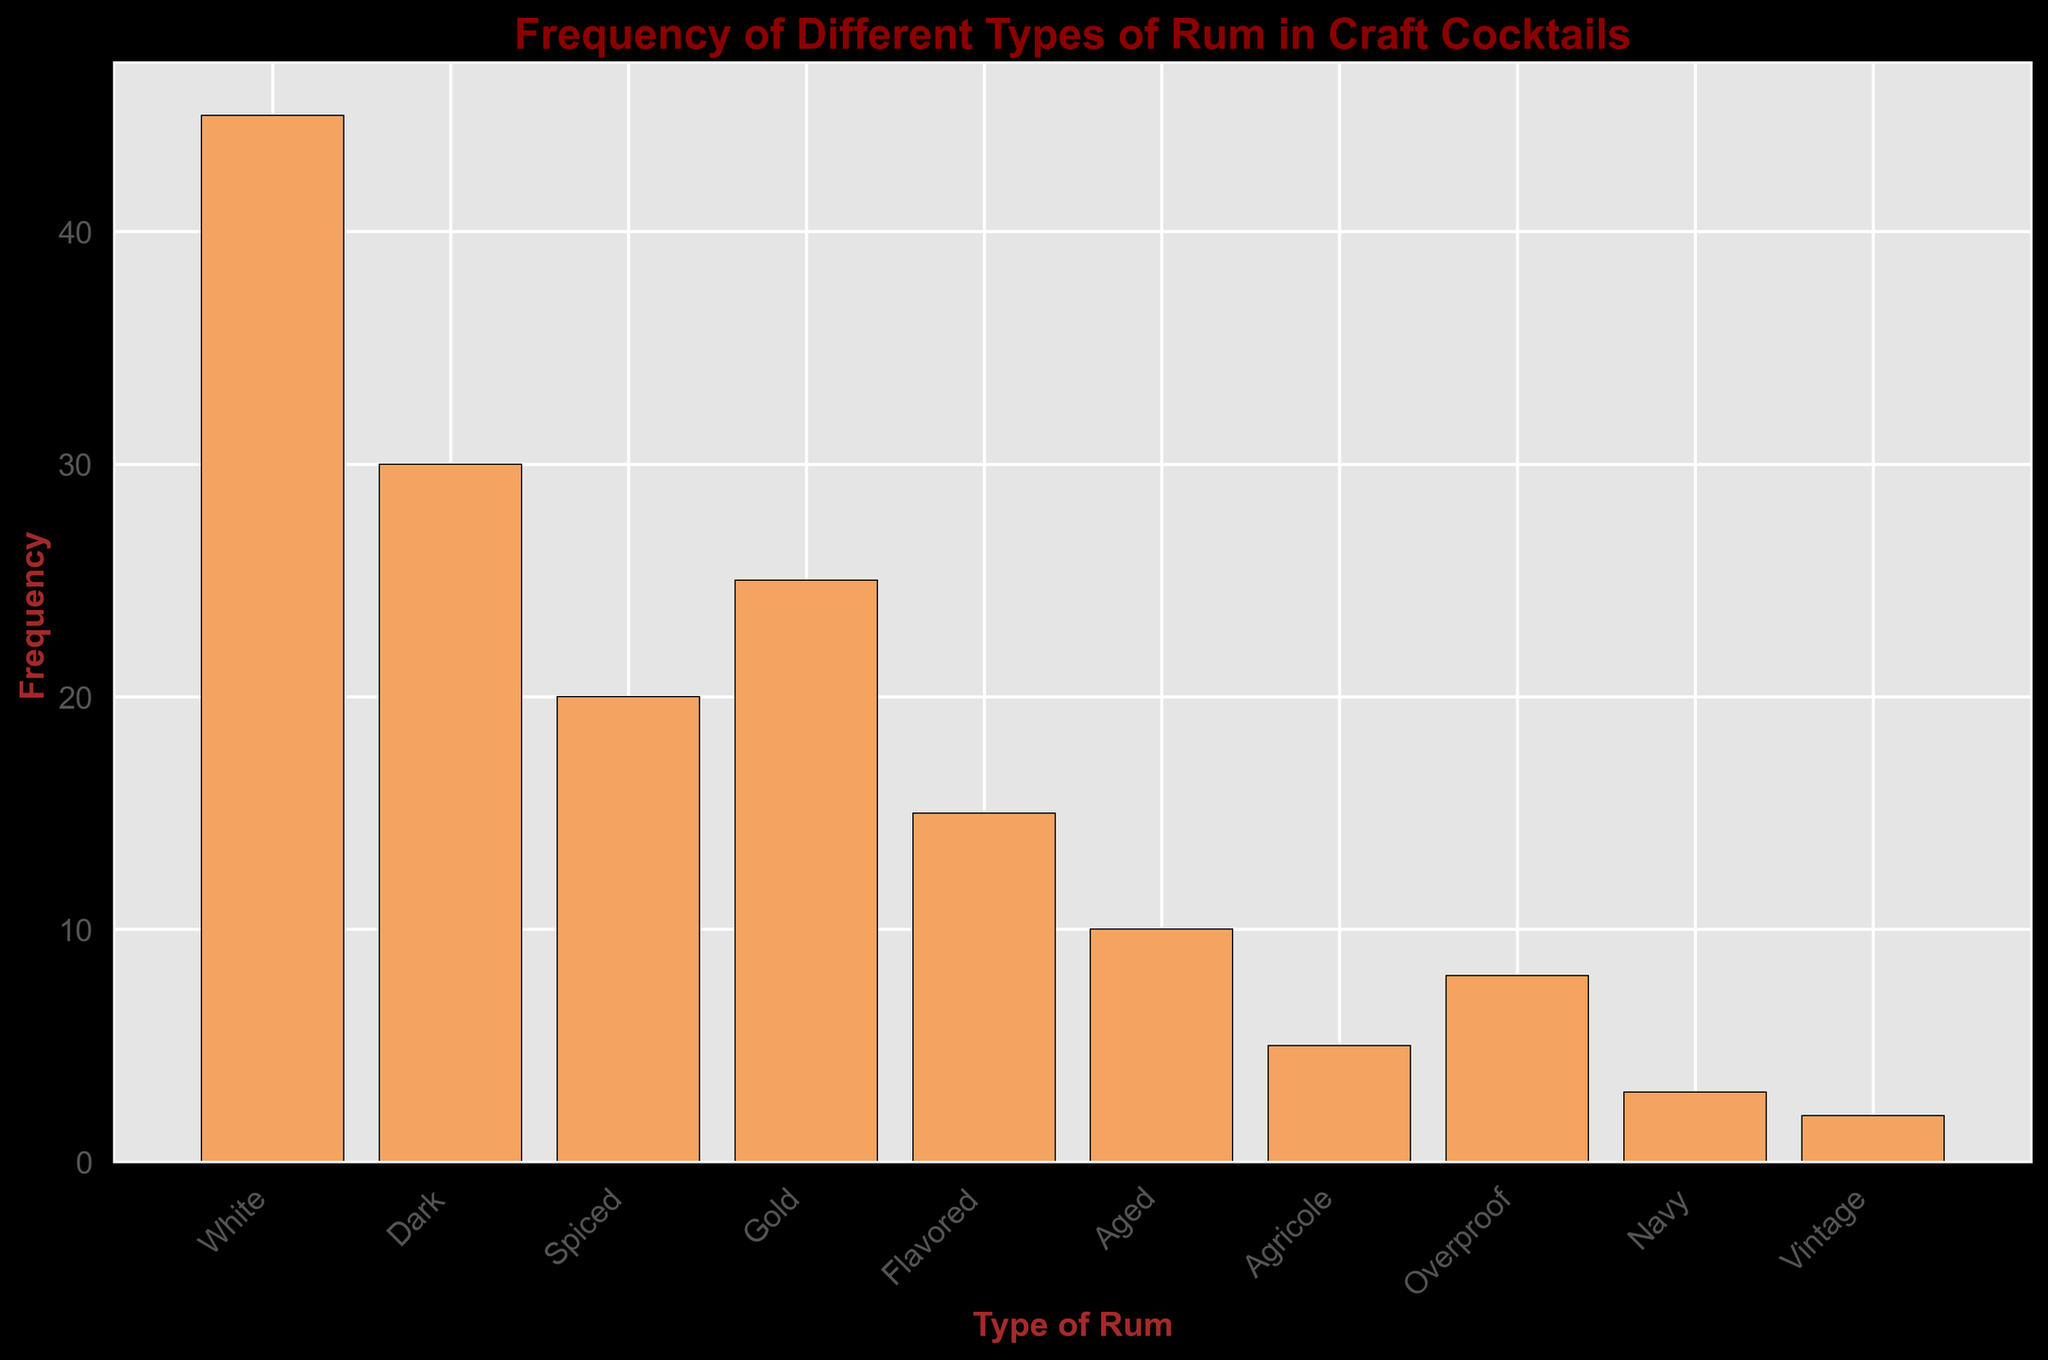Which type of rum is used most frequently in craft cocktails? The tallest bar in the histogram represents the highest frequency, which corresponds to the White rum.
Answer: White How many types of rum have a frequency of more than 20? The bars representing White, Dark, Spiced, and Gold rums all exceed a frequency of 20.
Answer: 4 What is the combined frequency of Flavored and Aged rums? Flavored rum has a frequency of 15, and Aged rum has a frequency of 10. Adding these together: 15 + 10 = 25.
Answer: 25 Which type of rum has the second-highest frequency? The bar for Dark rum is the second tallest after White rum.
Answer: Dark What is the difference in frequency between the most and least used types of rum? The frequency of White rum is 45, and the frequency of Vintage rum is 2. The difference is 45 - 2 = 43.
Answer: 43 Are there more rums with a frequency of 10 or less, or with a frequency greater than 10? Types with frequency of 10 or less: Aged (10), Agricole (5), Overproof (8), Navy (3), and Vintage (2). Types with frequency greater than 10: White (45), Dark (30), Spiced (20), Gold (25), and Flavored (15). There are five types in each category.
Answer: Equal Which type of rum has the lowest frequency? The shortest bar in the histogram represents the lowest frequency, corresponding to Vintage rum.
Answer: Vintage How does the frequency of Spiced rum compare to Gold rum? The bar for Spiced rum is shorter than the bar for Gold rum, indicating a lower frequency for Spiced rum (20) compared to Gold rum (25).
Answer: Less What is the total frequency of all rum types in the histogram? Adding the frequencies of all rum types: 45 + 30 + 20 + 25 + 15 + 10 + 5 + 8 + 3 + 2 = 163.
Answer: 163 How many rum types have a frequency that falls between 5 and 15 inclusive? The frequencies between 5 and 15 are Flavored (15), Aged (10), and Overproof (8).
Answer: 3 